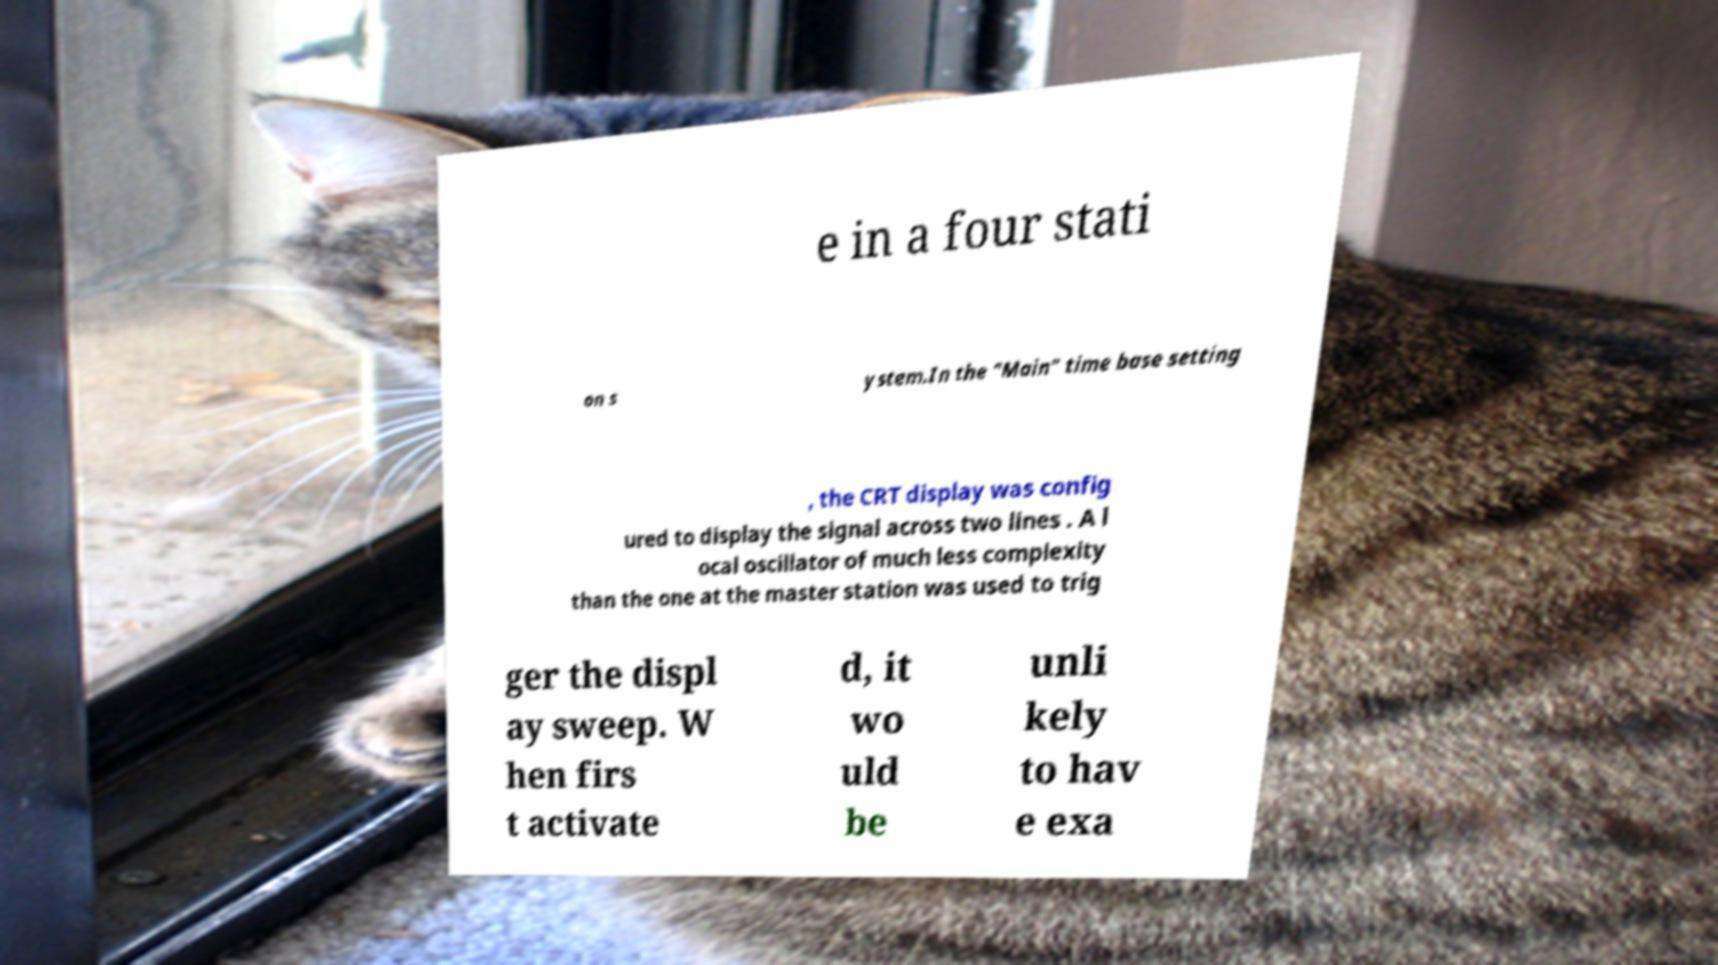What messages or text are displayed in this image? I need them in a readable, typed format. e in a four stati on s ystem.In the "Main" time base setting , the CRT display was config ured to display the signal across two lines . A l ocal oscillator of much less complexity than the one at the master station was used to trig ger the displ ay sweep. W hen firs t activate d, it wo uld be unli kely to hav e exa 